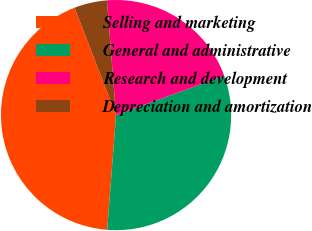Convert chart to OTSL. <chart><loc_0><loc_0><loc_500><loc_500><pie_chart><fcel>Selling and marketing<fcel>General and administrative<fcel>Research and development<fcel>Depreciation and amortization<nl><fcel>42.89%<fcel>31.77%<fcel>20.72%<fcel>4.61%<nl></chart> 